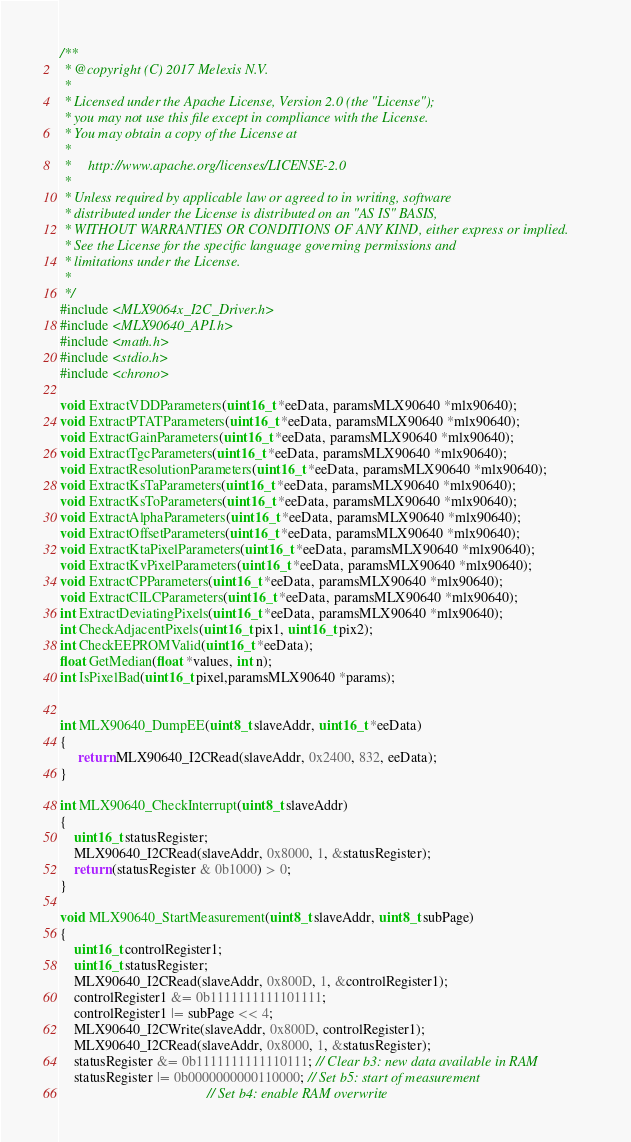Convert code to text. <code><loc_0><loc_0><loc_500><loc_500><_C++_>/**
 * @copyright (C) 2017 Melexis N.V.
 *
 * Licensed under the Apache License, Version 2.0 (the "License");
 * you may not use this file except in compliance with the License.
 * You may obtain a copy of the License at
 *
 *     http://www.apache.org/licenses/LICENSE-2.0
 *
 * Unless required by applicable law or agreed to in writing, software
 * distributed under the License is distributed on an "AS IS" BASIS,
 * WITHOUT WARRANTIES OR CONDITIONS OF ANY KIND, either express or implied.
 * See the License for the specific language governing permissions and
 * limitations under the License.
 *
 */
#include <MLX9064x_I2C_Driver.h>
#include <MLX90640_API.h>
#include <math.h>
#include <stdio.h>
#include <chrono>

void ExtractVDDParameters(uint16_t *eeData, paramsMLX90640 *mlx90640);
void ExtractPTATParameters(uint16_t *eeData, paramsMLX90640 *mlx90640);
void ExtractGainParameters(uint16_t *eeData, paramsMLX90640 *mlx90640);
void ExtractTgcParameters(uint16_t *eeData, paramsMLX90640 *mlx90640);
void ExtractResolutionParameters(uint16_t *eeData, paramsMLX90640 *mlx90640);
void ExtractKsTaParameters(uint16_t *eeData, paramsMLX90640 *mlx90640);
void ExtractKsToParameters(uint16_t *eeData, paramsMLX90640 *mlx90640);
void ExtractAlphaParameters(uint16_t *eeData, paramsMLX90640 *mlx90640);
void ExtractOffsetParameters(uint16_t *eeData, paramsMLX90640 *mlx90640);
void ExtractKtaPixelParameters(uint16_t *eeData, paramsMLX90640 *mlx90640);
void ExtractKvPixelParameters(uint16_t *eeData, paramsMLX90640 *mlx90640);
void ExtractCPParameters(uint16_t *eeData, paramsMLX90640 *mlx90640);
void ExtractCILCParameters(uint16_t *eeData, paramsMLX90640 *mlx90640);
int ExtractDeviatingPixels(uint16_t *eeData, paramsMLX90640 *mlx90640);
int CheckAdjacentPixels(uint16_t pix1, uint16_t pix2);
int CheckEEPROMValid(uint16_t *eeData);  
float GetMedian(float *values, int n);
int IsPixelBad(uint16_t pixel,paramsMLX90640 *params);

  
int MLX90640_DumpEE(uint8_t slaveAddr, uint16_t *eeData)
{
     return MLX90640_I2CRead(slaveAddr, 0x2400, 832, eeData);
}

int MLX90640_CheckInterrupt(uint8_t slaveAddr)
{
    uint16_t statusRegister;
    MLX90640_I2CRead(slaveAddr, 0x8000, 1, &statusRegister);
    return (statusRegister & 0b1000) > 0;
}

void MLX90640_StartMeasurement(uint8_t slaveAddr, uint8_t subPage)
{
    uint16_t controlRegister1;
    uint16_t statusRegister;
    MLX90640_I2CRead(slaveAddr, 0x800D, 1, &controlRegister1);
    controlRegister1 &= 0b1111111111101111;
    controlRegister1 |= subPage << 4;
    MLX90640_I2CWrite(slaveAddr, 0x800D, controlRegister1);
    MLX90640_I2CRead(slaveAddr, 0x8000, 1, &statusRegister);
    statusRegister &= 0b1111111111110111; // Clear b3: new data available in RAM
    statusRegister |= 0b0000000000110000; // Set b5: start of measurement
                                          // Set b4: enable RAM overwrite</code> 